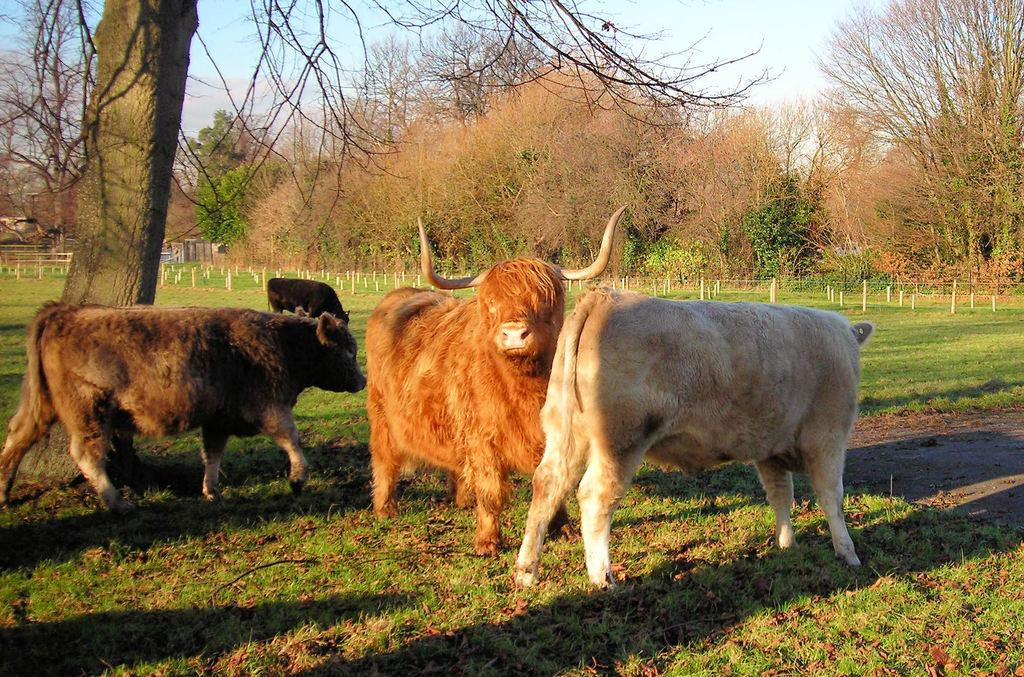How many animals are present in the image? There are four animals standing in the image. What type of vegetation can be seen in the image? There is grass in the image. What structures are present in the image? There are poles in the image. What else can be seen in the image besides the animals and vegetation? There are trees in the image. What is visible in the background of the image? The sky is visible in the background of the image. Where is the basket located in the image? There is no basket present in the image. What type of chicken can be seen in the image? There are no chickens present in the image; the animals are not specified. 